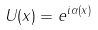Convert formula to latex. <formula><loc_0><loc_0><loc_500><loc_500>U ( x ) = e ^ { i \alpha ( x ) }</formula> 